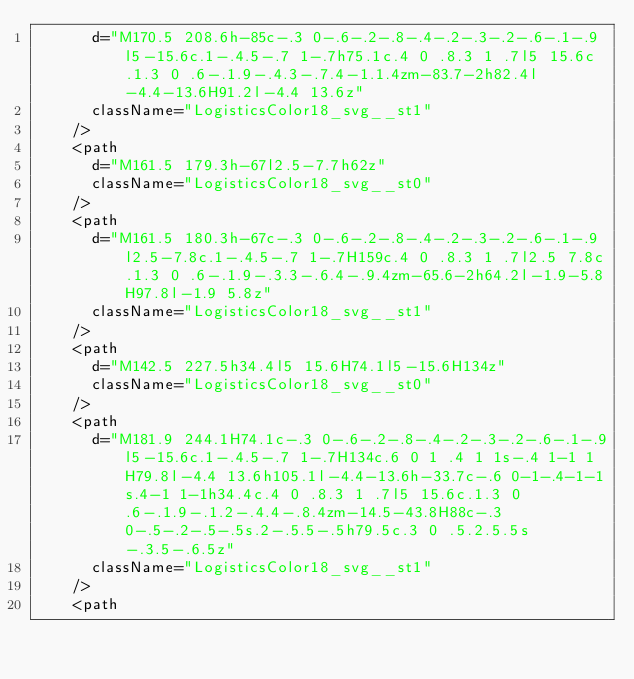<code> <loc_0><loc_0><loc_500><loc_500><_TypeScript_>      d="M170.5 208.6h-85c-.3 0-.6-.2-.8-.4-.2-.3-.2-.6-.1-.9l5-15.6c.1-.4.5-.7 1-.7h75.1c.4 0 .8.3 1 .7l5 15.6c.1.3 0 .6-.1.9-.4.3-.7.4-1.1.4zm-83.7-2h82.4l-4.4-13.6H91.2l-4.4 13.6z"
      className="LogisticsColor18_svg__st1"
    />
    <path
      d="M161.5 179.3h-67l2.5-7.7h62z"
      className="LogisticsColor18_svg__st0"
    />
    <path
      d="M161.5 180.3h-67c-.3 0-.6-.2-.8-.4-.2-.3-.2-.6-.1-.9l2.5-7.8c.1-.4.5-.7 1-.7H159c.4 0 .8.3 1 .7l2.5 7.8c.1.3 0 .6-.1.9-.3.3-.6.4-.9.4zm-65.6-2h64.2l-1.9-5.8H97.8l-1.9 5.8z"
      className="LogisticsColor18_svg__st1"
    />
    <path
      d="M142.5 227.5h34.4l5 15.6H74.1l5-15.6H134z"
      className="LogisticsColor18_svg__st0"
    />
    <path
      d="M181.9 244.1H74.1c-.3 0-.6-.2-.8-.4-.2-.3-.2-.6-.1-.9l5-15.6c.1-.4.5-.7 1-.7H134c.6 0 1 .4 1 1s-.4 1-1 1H79.8l-4.4 13.6h105.1l-4.4-13.6h-33.7c-.6 0-1-.4-1-1s.4-1 1-1h34.4c.4 0 .8.3 1 .7l5 15.6c.1.3 0 .6-.1.9-.1.2-.4.4-.8.4zm-14.5-43.8H88c-.3 0-.5-.2-.5-.5s.2-.5.5-.5h79.5c.3 0 .5.2.5.5s-.3.5-.6.5z"
      className="LogisticsColor18_svg__st1"
    />
    <path</code> 